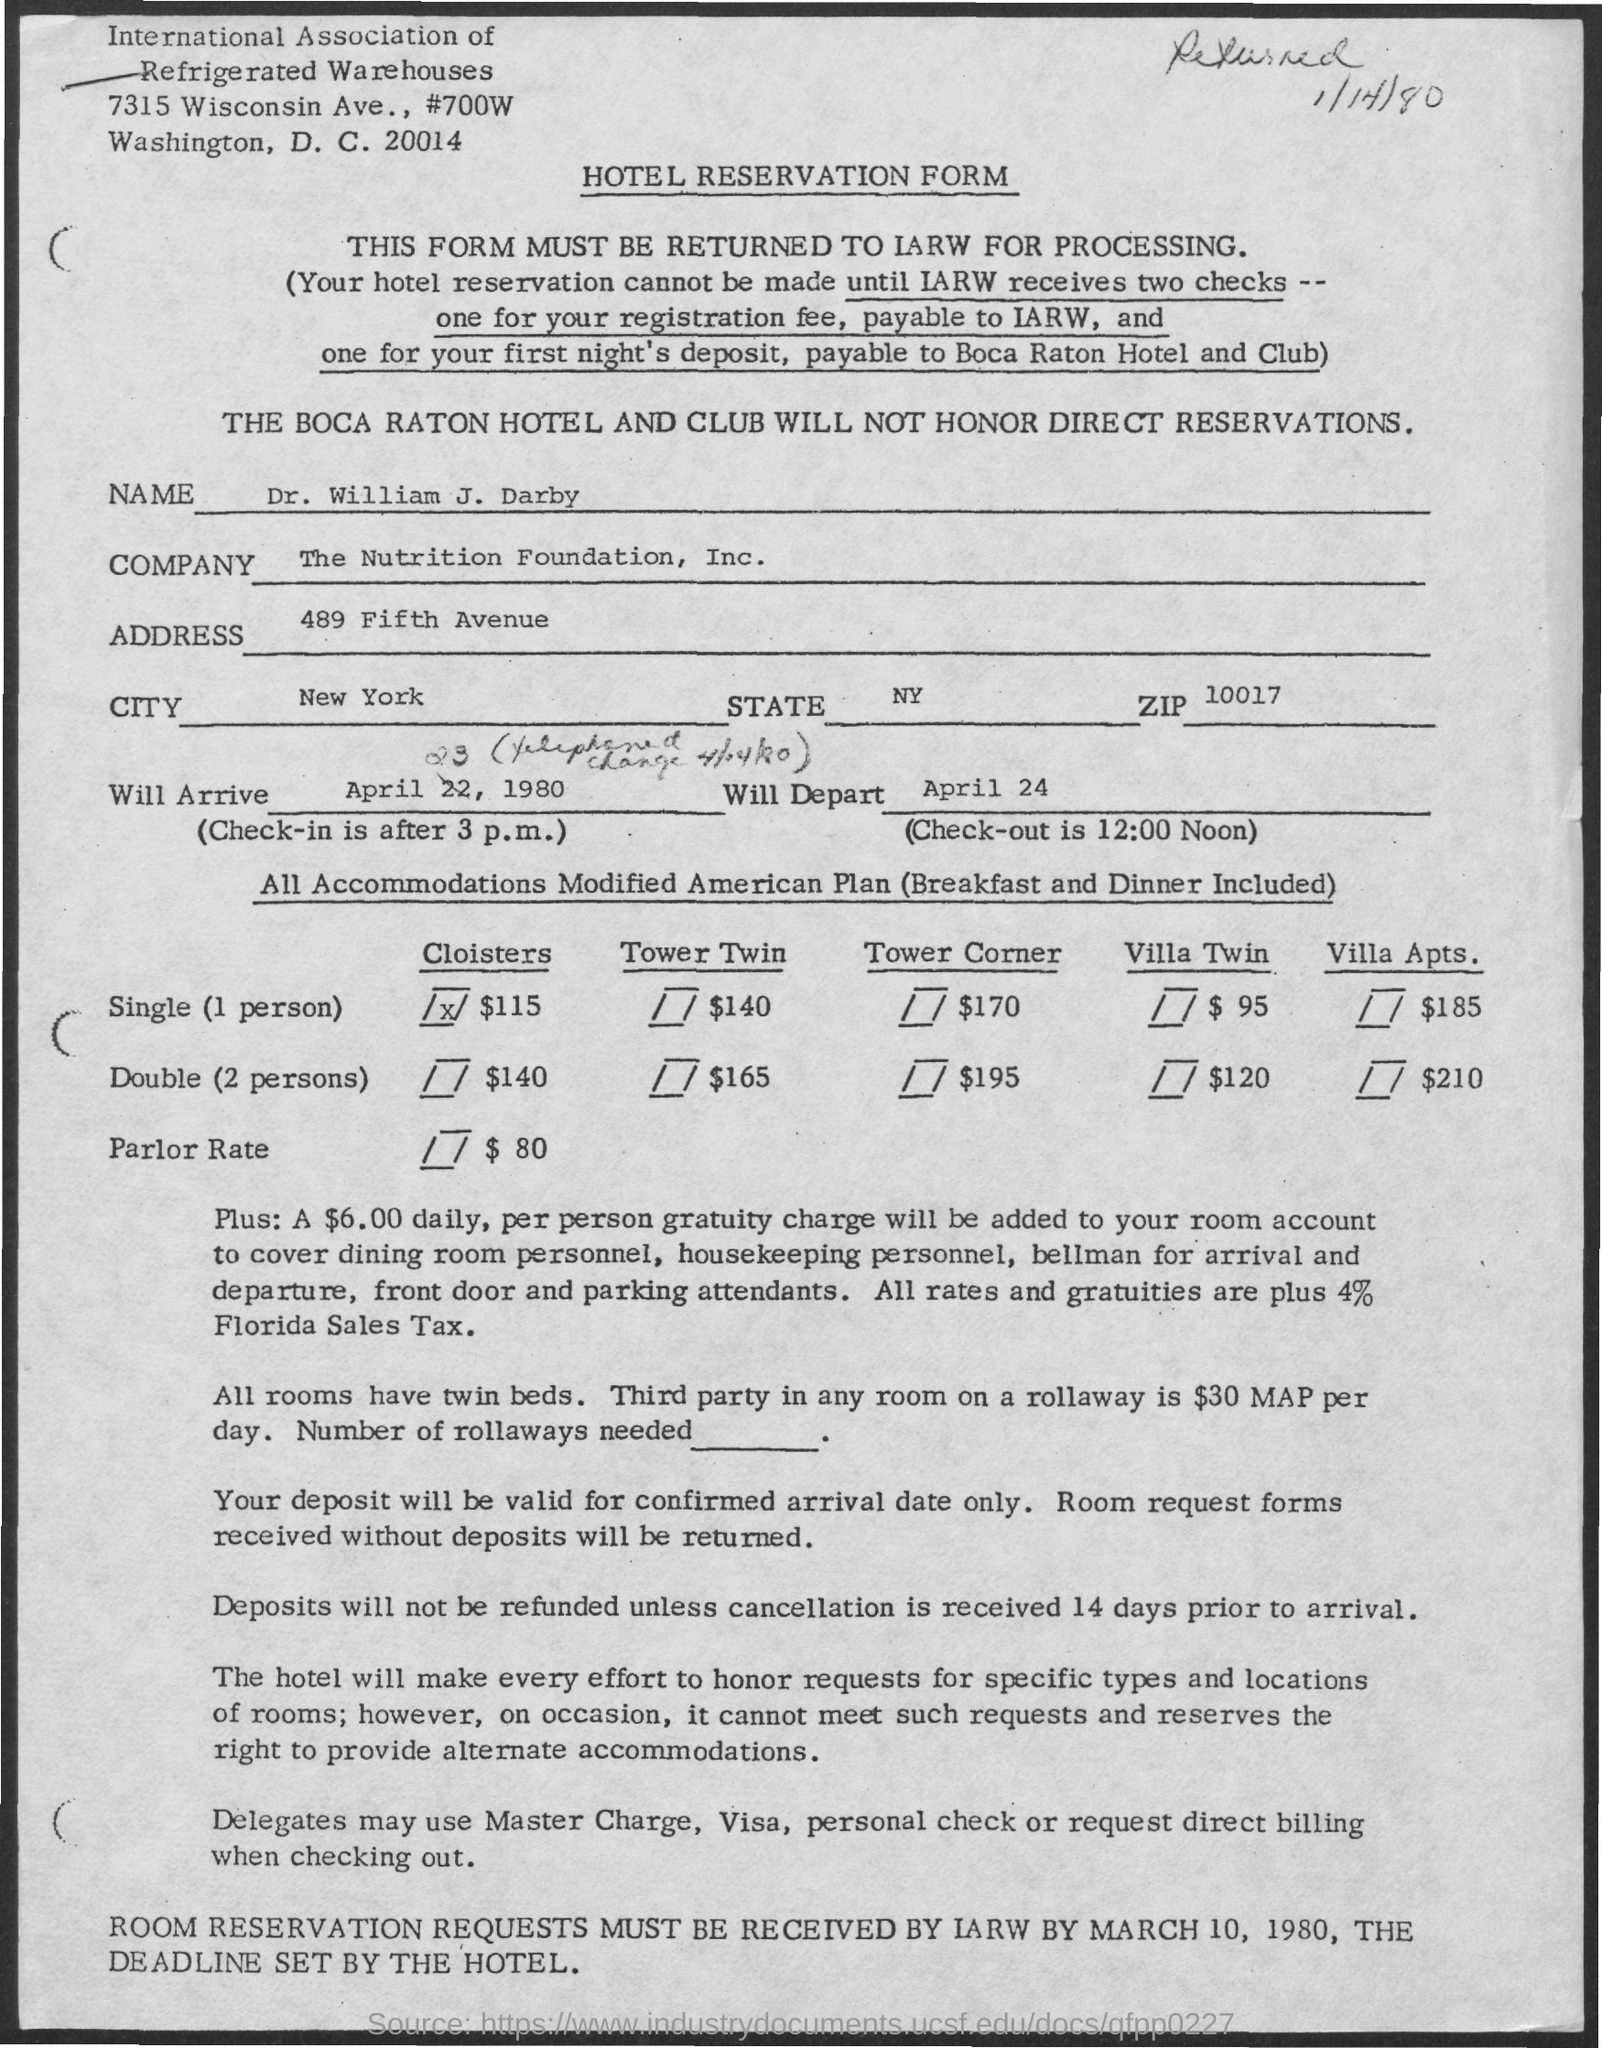Can you tell me what the document is about? The image shows a hotel reservation form for The Boca Raton Hotel and Club. It includes information about room rates, payment options, and reservation instructions. What are the terms for the reservation deposits and refunds? Deposits are only valid for the confirmed arrival date and will be returned if not accompanied by a deposit. Refunds are only issued for cancellations received 14 days prior to arrival. 